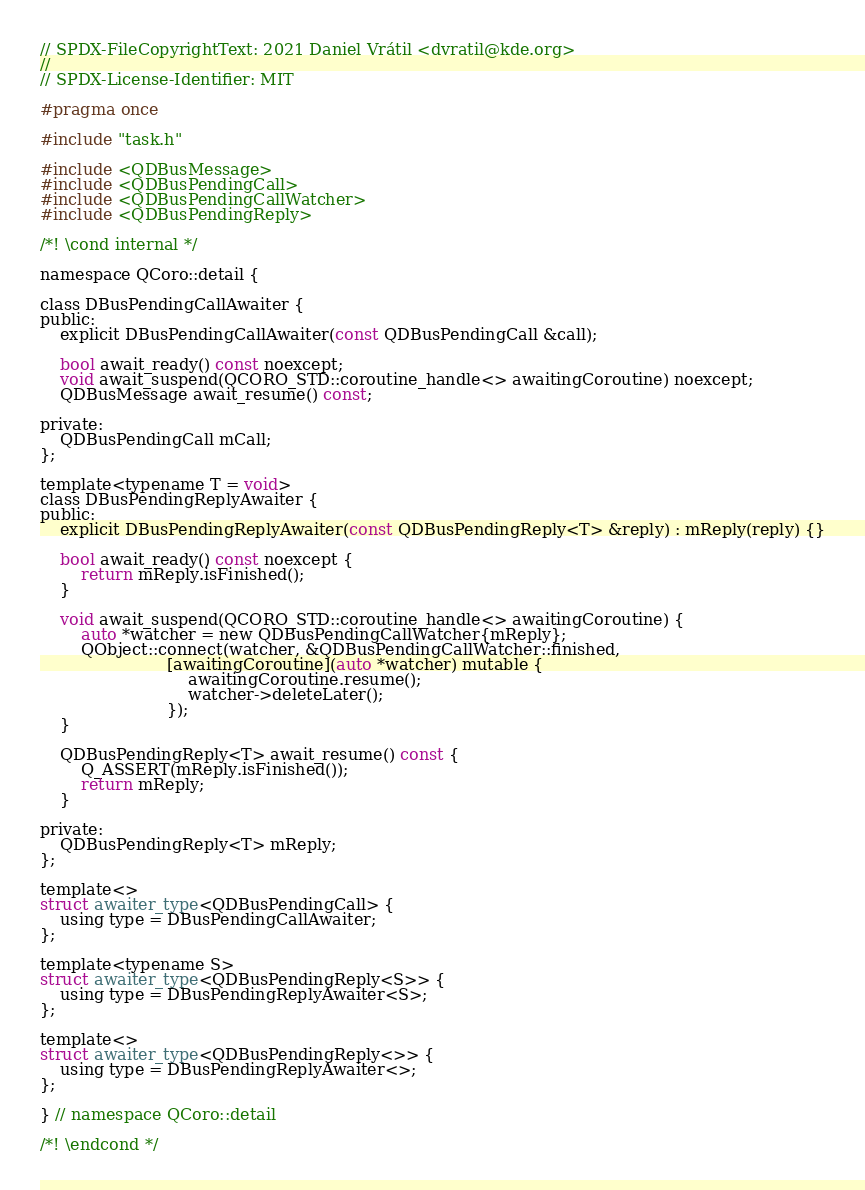<code> <loc_0><loc_0><loc_500><loc_500><_C_>// SPDX-FileCopyrightText: 2021 Daniel Vrátil <dvratil@kde.org>
//
// SPDX-License-Identifier: MIT

#pragma once

#include "task.h"

#include <QDBusMessage>
#include <QDBusPendingCall>
#include <QDBusPendingCallWatcher>
#include <QDBusPendingReply>

/*! \cond internal */

namespace QCoro::detail {

class DBusPendingCallAwaiter {
public:
    explicit DBusPendingCallAwaiter(const QDBusPendingCall &call);

    bool await_ready() const noexcept;
    void await_suspend(QCORO_STD::coroutine_handle<> awaitingCoroutine) noexcept;
    QDBusMessage await_resume() const;

private:
    QDBusPendingCall mCall;
};

template<typename T = void>
class DBusPendingReplyAwaiter {
public:
    explicit DBusPendingReplyAwaiter(const QDBusPendingReply<T> &reply) : mReply(reply) {}

    bool await_ready() const noexcept {
        return mReply.isFinished();
    }

    void await_suspend(QCORO_STD::coroutine_handle<> awaitingCoroutine) {
        auto *watcher = new QDBusPendingCallWatcher{mReply};
        QObject::connect(watcher, &QDBusPendingCallWatcher::finished,
                         [awaitingCoroutine](auto *watcher) mutable {
                             awaitingCoroutine.resume();
                             watcher->deleteLater();
                         });
    }

    QDBusPendingReply<T> await_resume() const {
        Q_ASSERT(mReply.isFinished());
        return mReply;
    }

private:
    QDBusPendingReply<T> mReply;
};

template<>
struct awaiter_type<QDBusPendingCall> {
    using type = DBusPendingCallAwaiter;
};

template<typename S>
struct awaiter_type<QDBusPendingReply<S>> {
    using type = DBusPendingReplyAwaiter<S>;
};

template<>
struct awaiter_type<QDBusPendingReply<>> {
    using type = DBusPendingReplyAwaiter<>;
};

} // namespace QCoro::detail

/*! \endcond */
</code> 